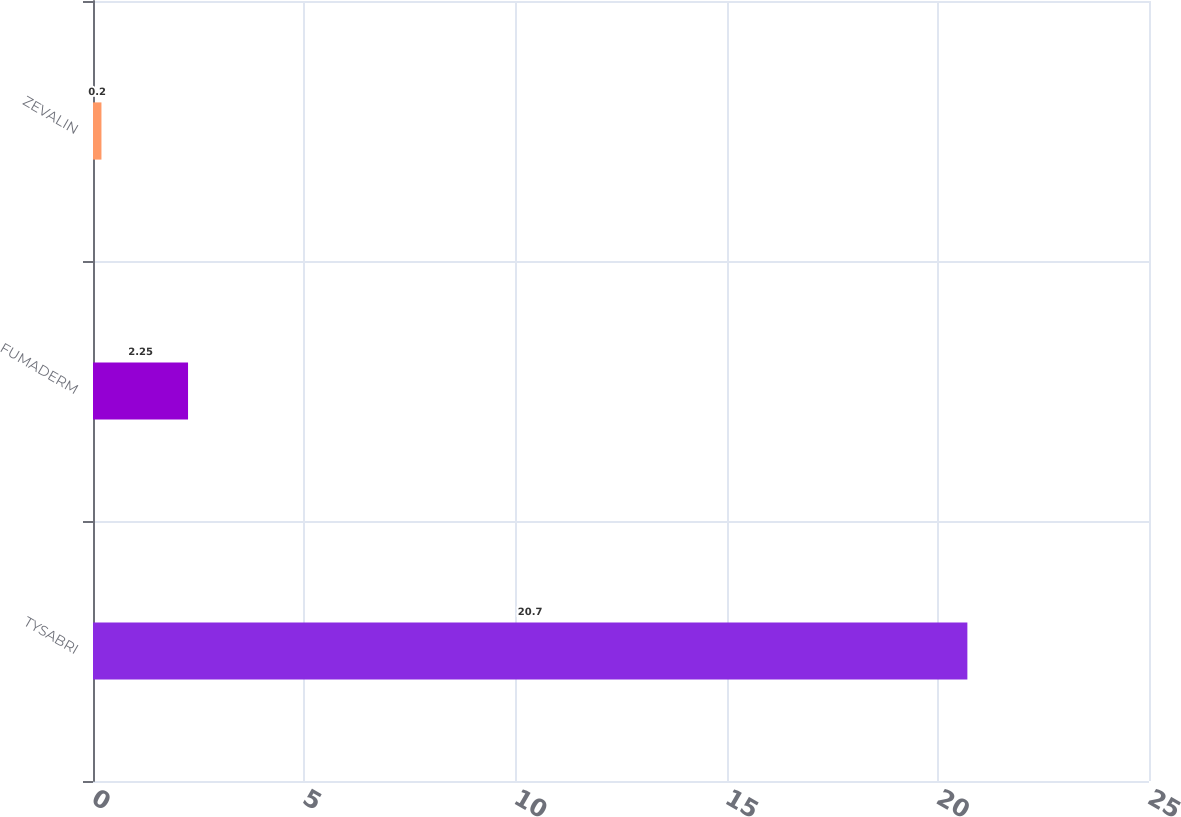<chart> <loc_0><loc_0><loc_500><loc_500><bar_chart><fcel>TYSABRI<fcel>FUMADERM<fcel>ZEVALIN<nl><fcel>20.7<fcel>2.25<fcel>0.2<nl></chart> 